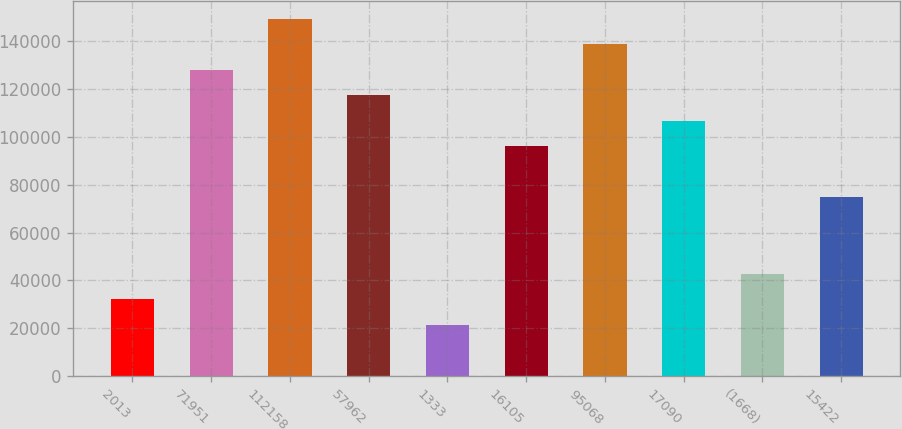Convert chart to OTSL. <chart><loc_0><loc_0><loc_500><loc_500><bar_chart><fcel>2013<fcel>71951<fcel>112158<fcel>57962<fcel>1333<fcel>16105<fcel>95068<fcel>17090<fcel>(1668)<fcel>15422<nl><fcel>32055.2<fcel>128134<fcel>149485<fcel>117458<fcel>21379.8<fcel>96107.6<fcel>138809<fcel>106783<fcel>42730.6<fcel>74756.8<nl></chart> 